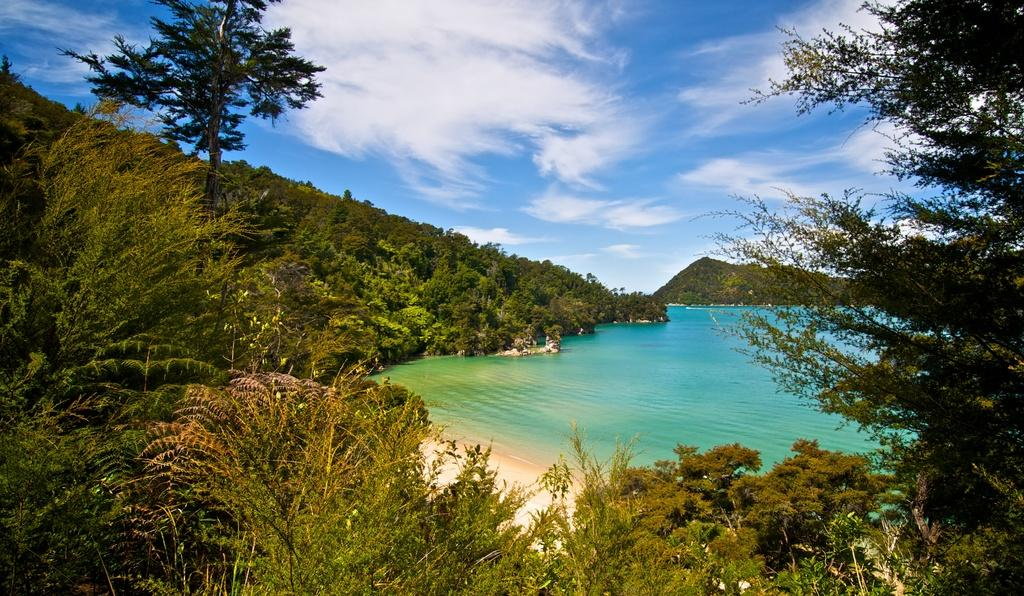What type of natural environment is depicted in the image? The image features trees, a river, and a mountain in the background, indicating a natural environment. Can you describe the water element in the image? There is a river in the image. What is visible in the background of the image? There is a mountain in the background of the image. What part of the sky can be seen in the image? The sky is visible in the image. What direction is the maid walking in the image? There is no maid present in the image, so it is not possible to answer that question. 